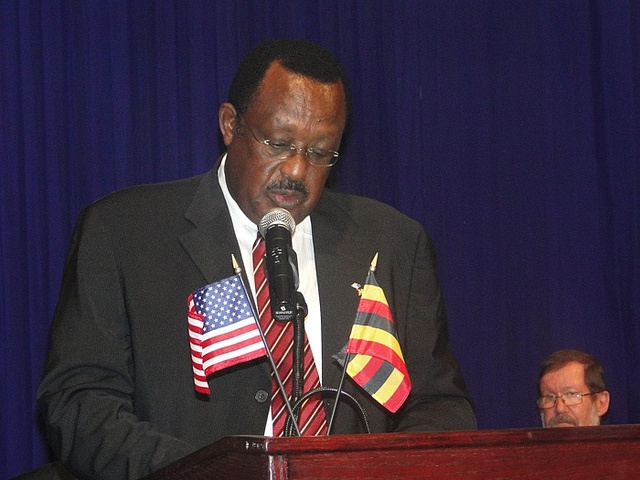Describe the objects in this image and their specific colors. I can see people in navy, black, maroon, gray, and white tones, tie in navy, maroon, and brown tones, and people in navy, maroon, brown, and salmon tones in this image. 